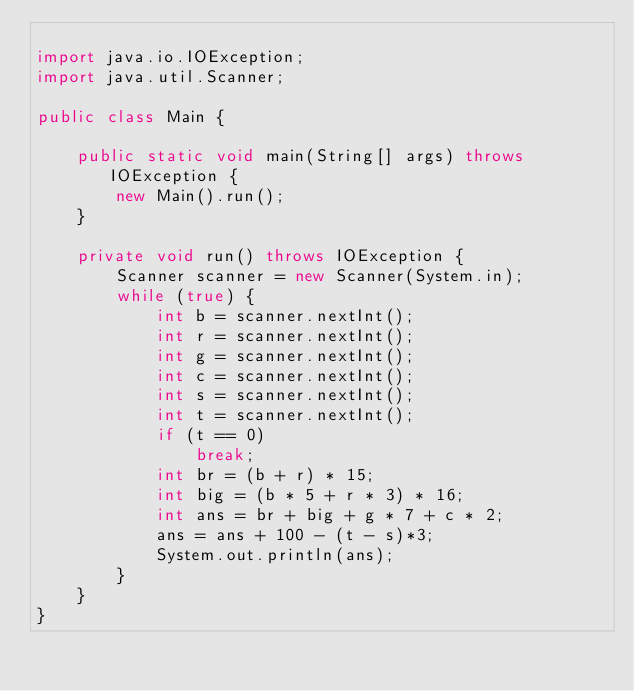Convert code to text. <code><loc_0><loc_0><loc_500><loc_500><_Java_>
import java.io.IOException;
import java.util.Scanner;

public class Main {

	public static void main(String[] args) throws IOException {
		new Main().run();
	}

	private void run() throws IOException {
		Scanner scanner = new Scanner(System.in);
		while (true) {
			int b = scanner.nextInt();
			int r = scanner.nextInt();
			int g = scanner.nextInt();
			int c = scanner.nextInt();
			int s = scanner.nextInt();
			int t = scanner.nextInt();
			if (t == 0)
				break;
			int br = (b + r) * 15;
			int big = (b * 5 + r * 3) * 16;
			int ans = br + big + g * 7 + c * 2;
			ans = ans + 100 - (t - s)*3;
			System.out.println(ans);
		}
	}
}</code> 